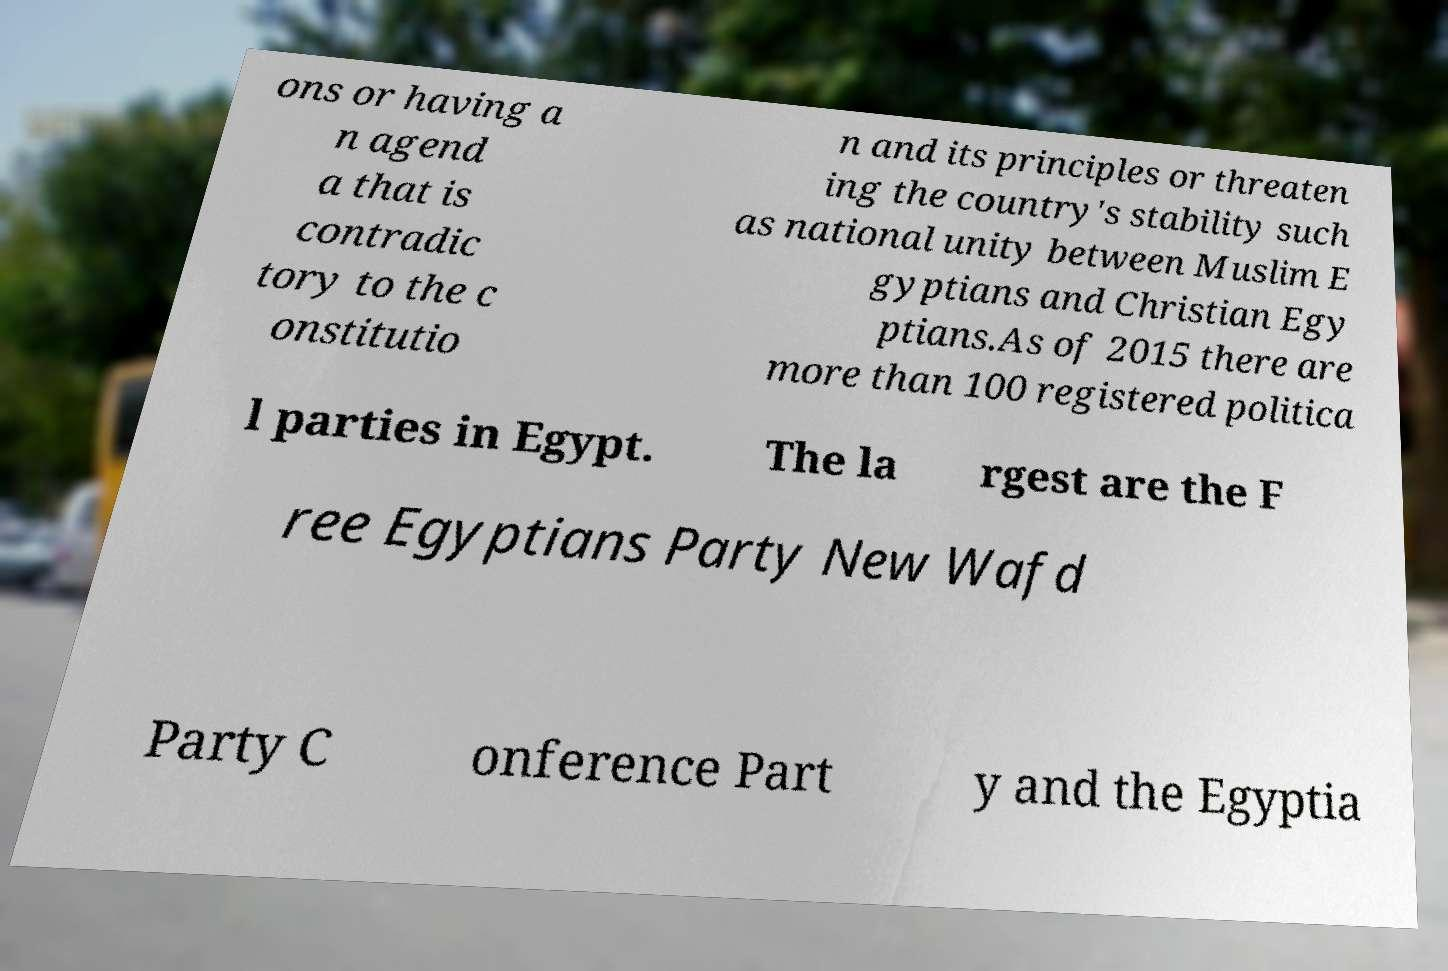What messages or text are displayed in this image? I need them in a readable, typed format. ons or having a n agend a that is contradic tory to the c onstitutio n and its principles or threaten ing the country's stability such as national unity between Muslim E gyptians and Christian Egy ptians.As of 2015 there are more than 100 registered politica l parties in Egypt. The la rgest are the F ree Egyptians Party New Wafd Party C onference Part y and the Egyptia 